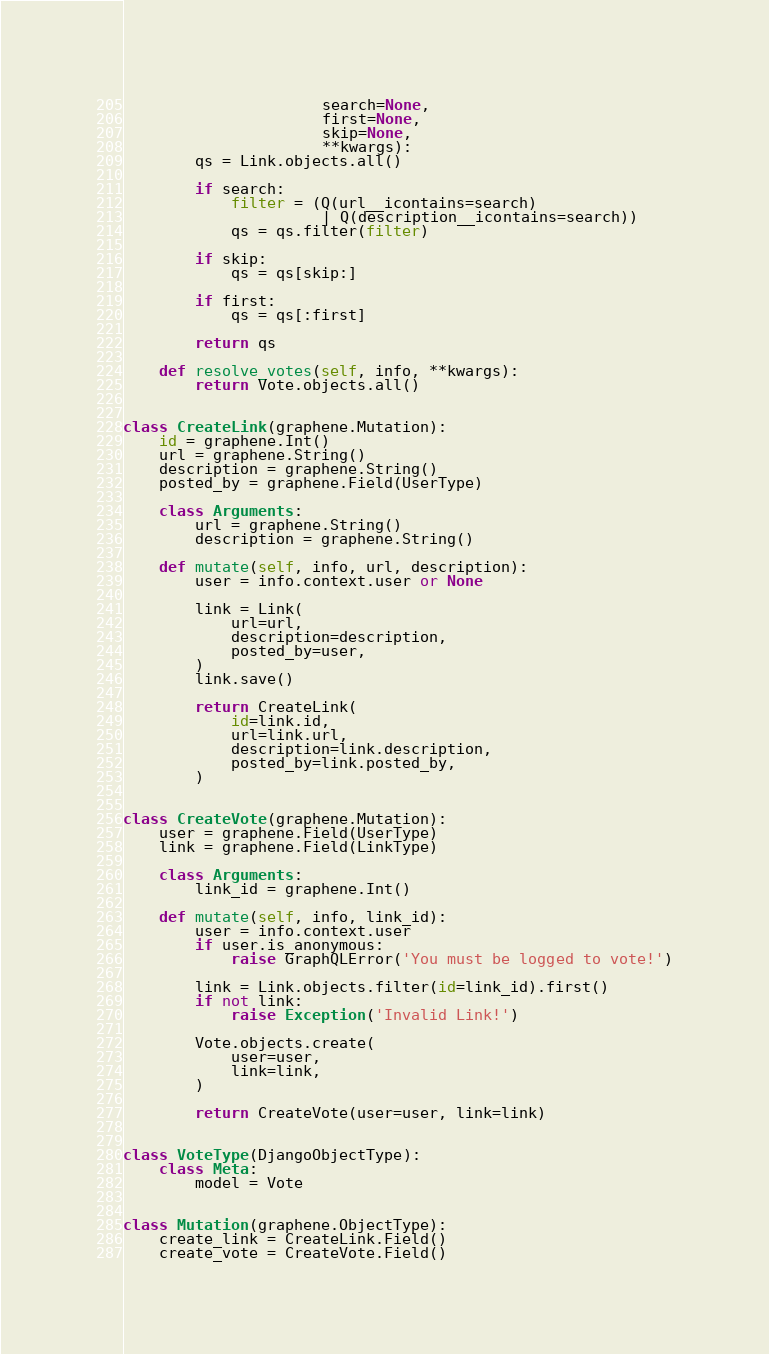<code> <loc_0><loc_0><loc_500><loc_500><_Python_>                      search=None,
                      first=None,
                      skip=None,
                      **kwargs):
        qs = Link.objects.all()

        if search:
            filter = (Q(url__icontains=search)
                      | Q(description__icontains=search))
            qs = qs.filter(filter)

        if skip:
            qs = qs[skip:]

        if first:
            qs = qs[:first]

        return qs

    def resolve_votes(self, info, **kwargs):
        return Vote.objects.all()


class CreateLink(graphene.Mutation):
    id = graphene.Int()
    url = graphene.String()
    description = graphene.String()
    posted_by = graphene.Field(UserType)

    class Arguments:
        url = graphene.String()
        description = graphene.String()

    def mutate(self, info, url, description):
        user = info.context.user or None

        link = Link(
            url=url,
            description=description,
            posted_by=user,
        )
        link.save()

        return CreateLink(
            id=link.id,
            url=link.url,
            description=link.description,
            posted_by=link.posted_by,
        )


class CreateVote(graphene.Mutation):
    user = graphene.Field(UserType)
    link = graphene.Field(LinkType)

    class Arguments:
        link_id = graphene.Int()

    def mutate(self, info, link_id):
        user = info.context.user
        if user.is_anonymous:
            raise GraphQLError('You must be logged to vote!')

        link = Link.objects.filter(id=link_id).first()
        if not link:
            raise Exception('Invalid Link!')

        Vote.objects.create(
            user=user,
            link=link,
        )

        return CreateVote(user=user, link=link)


class VoteType(DjangoObjectType):
    class Meta:
        model = Vote


class Mutation(graphene.ObjectType):
    create_link = CreateLink.Field()
    create_vote = CreateVote.Field()
</code> 